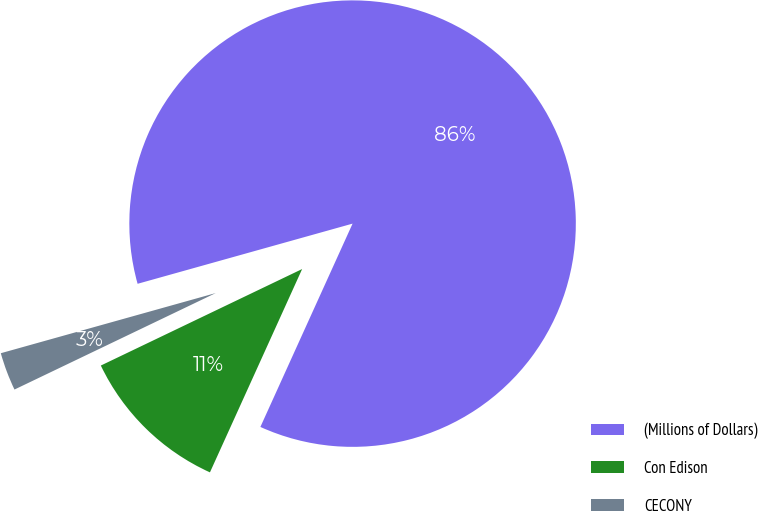Convert chart to OTSL. <chart><loc_0><loc_0><loc_500><loc_500><pie_chart><fcel>(Millions of Dollars)<fcel>Con Edison<fcel>CECONY<nl><fcel>86.12%<fcel>11.11%<fcel>2.77%<nl></chart> 